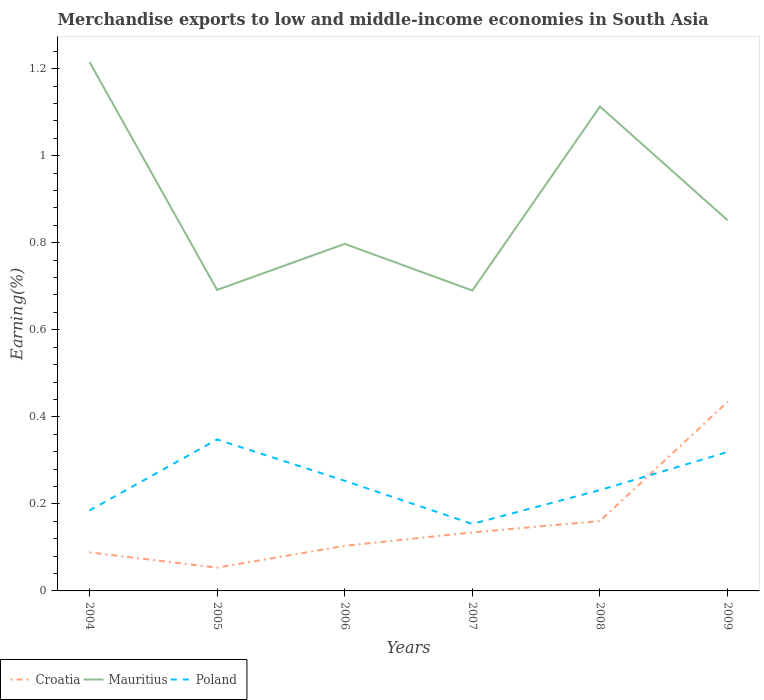How many different coloured lines are there?
Make the answer very short. 3. Does the line corresponding to Croatia intersect with the line corresponding to Poland?
Offer a very short reply. Yes. Across all years, what is the maximum percentage of amount earned from merchandise exports in Poland?
Your answer should be very brief. 0.15. What is the total percentage of amount earned from merchandise exports in Mauritius in the graph?
Provide a succinct answer. 0.36. What is the difference between the highest and the second highest percentage of amount earned from merchandise exports in Poland?
Give a very brief answer. 0.19. How many lines are there?
Offer a terse response. 3. Does the graph contain any zero values?
Offer a terse response. No. Does the graph contain grids?
Make the answer very short. No. Where does the legend appear in the graph?
Provide a short and direct response. Bottom left. How many legend labels are there?
Offer a very short reply. 3. How are the legend labels stacked?
Provide a succinct answer. Horizontal. What is the title of the graph?
Offer a terse response. Merchandise exports to low and middle-income economies in South Asia. Does "Netherlands" appear as one of the legend labels in the graph?
Offer a terse response. No. What is the label or title of the Y-axis?
Provide a succinct answer. Earning(%). What is the Earning(%) of Croatia in 2004?
Provide a succinct answer. 0.09. What is the Earning(%) in Mauritius in 2004?
Make the answer very short. 1.22. What is the Earning(%) in Poland in 2004?
Offer a very short reply. 0.18. What is the Earning(%) of Croatia in 2005?
Give a very brief answer. 0.05. What is the Earning(%) in Mauritius in 2005?
Offer a terse response. 0.69. What is the Earning(%) in Poland in 2005?
Your answer should be very brief. 0.35. What is the Earning(%) of Croatia in 2006?
Your answer should be compact. 0.1. What is the Earning(%) in Mauritius in 2006?
Give a very brief answer. 0.8. What is the Earning(%) in Poland in 2006?
Keep it short and to the point. 0.25. What is the Earning(%) in Croatia in 2007?
Provide a short and direct response. 0.13. What is the Earning(%) of Mauritius in 2007?
Provide a succinct answer. 0.69. What is the Earning(%) of Poland in 2007?
Your answer should be compact. 0.15. What is the Earning(%) in Croatia in 2008?
Make the answer very short. 0.16. What is the Earning(%) in Mauritius in 2008?
Your answer should be compact. 1.11. What is the Earning(%) in Poland in 2008?
Offer a terse response. 0.23. What is the Earning(%) in Croatia in 2009?
Offer a terse response. 0.43. What is the Earning(%) of Mauritius in 2009?
Provide a succinct answer. 0.85. What is the Earning(%) in Poland in 2009?
Your response must be concise. 0.32. Across all years, what is the maximum Earning(%) in Croatia?
Keep it short and to the point. 0.43. Across all years, what is the maximum Earning(%) in Mauritius?
Make the answer very short. 1.22. Across all years, what is the maximum Earning(%) of Poland?
Provide a short and direct response. 0.35. Across all years, what is the minimum Earning(%) of Croatia?
Your response must be concise. 0.05. Across all years, what is the minimum Earning(%) of Mauritius?
Give a very brief answer. 0.69. Across all years, what is the minimum Earning(%) of Poland?
Your response must be concise. 0.15. What is the total Earning(%) of Croatia in the graph?
Offer a very short reply. 0.98. What is the total Earning(%) of Mauritius in the graph?
Ensure brevity in your answer.  5.36. What is the total Earning(%) of Poland in the graph?
Ensure brevity in your answer.  1.49. What is the difference between the Earning(%) of Croatia in 2004 and that in 2005?
Give a very brief answer. 0.04. What is the difference between the Earning(%) in Mauritius in 2004 and that in 2005?
Your answer should be very brief. 0.52. What is the difference between the Earning(%) of Poland in 2004 and that in 2005?
Ensure brevity in your answer.  -0.16. What is the difference between the Earning(%) of Croatia in 2004 and that in 2006?
Provide a short and direct response. -0.02. What is the difference between the Earning(%) in Mauritius in 2004 and that in 2006?
Offer a very short reply. 0.42. What is the difference between the Earning(%) in Poland in 2004 and that in 2006?
Your answer should be very brief. -0.07. What is the difference between the Earning(%) in Croatia in 2004 and that in 2007?
Your answer should be very brief. -0.05. What is the difference between the Earning(%) in Mauritius in 2004 and that in 2007?
Your answer should be very brief. 0.53. What is the difference between the Earning(%) in Poland in 2004 and that in 2007?
Your answer should be very brief. 0.03. What is the difference between the Earning(%) of Croatia in 2004 and that in 2008?
Provide a short and direct response. -0.07. What is the difference between the Earning(%) of Mauritius in 2004 and that in 2008?
Keep it short and to the point. 0.1. What is the difference between the Earning(%) in Poland in 2004 and that in 2008?
Keep it short and to the point. -0.05. What is the difference between the Earning(%) in Croatia in 2004 and that in 2009?
Make the answer very short. -0.35. What is the difference between the Earning(%) in Mauritius in 2004 and that in 2009?
Provide a succinct answer. 0.36. What is the difference between the Earning(%) in Poland in 2004 and that in 2009?
Your answer should be very brief. -0.13. What is the difference between the Earning(%) in Croatia in 2005 and that in 2006?
Your answer should be very brief. -0.05. What is the difference between the Earning(%) of Mauritius in 2005 and that in 2006?
Ensure brevity in your answer.  -0.11. What is the difference between the Earning(%) of Poland in 2005 and that in 2006?
Provide a succinct answer. 0.1. What is the difference between the Earning(%) in Croatia in 2005 and that in 2007?
Your response must be concise. -0.08. What is the difference between the Earning(%) of Mauritius in 2005 and that in 2007?
Your answer should be very brief. 0. What is the difference between the Earning(%) of Poland in 2005 and that in 2007?
Offer a terse response. 0.19. What is the difference between the Earning(%) in Croatia in 2005 and that in 2008?
Your answer should be very brief. -0.11. What is the difference between the Earning(%) of Mauritius in 2005 and that in 2008?
Provide a succinct answer. -0.42. What is the difference between the Earning(%) in Poland in 2005 and that in 2008?
Provide a succinct answer. 0.12. What is the difference between the Earning(%) in Croatia in 2005 and that in 2009?
Your answer should be very brief. -0.38. What is the difference between the Earning(%) in Mauritius in 2005 and that in 2009?
Your answer should be compact. -0.16. What is the difference between the Earning(%) of Poland in 2005 and that in 2009?
Give a very brief answer. 0.03. What is the difference between the Earning(%) in Croatia in 2006 and that in 2007?
Ensure brevity in your answer.  -0.03. What is the difference between the Earning(%) of Mauritius in 2006 and that in 2007?
Your answer should be very brief. 0.11. What is the difference between the Earning(%) in Poland in 2006 and that in 2007?
Give a very brief answer. 0.1. What is the difference between the Earning(%) of Croatia in 2006 and that in 2008?
Provide a short and direct response. -0.06. What is the difference between the Earning(%) in Mauritius in 2006 and that in 2008?
Your answer should be very brief. -0.32. What is the difference between the Earning(%) in Poland in 2006 and that in 2008?
Your response must be concise. 0.02. What is the difference between the Earning(%) of Croatia in 2006 and that in 2009?
Your answer should be compact. -0.33. What is the difference between the Earning(%) in Mauritius in 2006 and that in 2009?
Provide a short and direct response. -0.05. What is the difference between the Earning(%) in Poland in 2006 and that in 2009?
Ensure brevity in your answer.  -0.07. What is the difference between the Earning(%) in Croatia in 2007 and that in 2008?
Give a very brief answer. -0.03. What is the difference between the Earning(%) in Mauritius in 2007 and that in 2008?
Provide a succinct answer. -0.42. What is the difference between the Earning(%) of Poland in 2007 and that in 2008?
Offer a terse response. -0.08. What is the difference between the Earning(%) of Croatia in 2007 and that in 2009?
Provide a short and direct response. -0.3. What is the difference between the Earning(%) of Mauritius in 2007 and that in 2009?
Make the answer very short. -0.16. What is the difference between the Earning(%) of Poland in 2007 and that in 2009?
Your response must be concise. -0.17. What is the difference between the Earning(%) in Croatia in 2008 and that in 2009?
Provide a succinct answer. -0.27. What is the difference between the Earning(%) of Mauritius in 2008 and that in 2009?
Your answer should be compact. 0.26. What is the difference between the Earning(%) in Poland in 2008 and that in 2009?
Your answer should be compact. -0.09. What is the difference between the Earning(%) in Croatia in 2004 and the Earning(%) in Mauritius in 2005?
Give a very brief answer. -0.6. What is the difference between the Earning(%) of Croatia in 2004 and the Earning(%) of Poland in 2005?
Your answer should be very brief. -0.26. What is the difference between the Earning(%) in Mauritius in 2004 and the Earning(%) in Poland in 2005?
Keep it short and to the point. 0.87. What is the difference between the Earning(%) of Croatia in 2004 and the Earning(%) of Mauritius in 2006?
Give a very brief answer. -0.71. What is the difference between the Earning(%) in Croatia in 2004 and the Earning(%) in Poland in 2006?
Provide a succinct answer. -0.16. What is the difference between the Earning(%) of Mauritius in 2004 and the Earning(%) of Poland in 2006?
Keep it short and to the point. 0.96. What is the difference between the Earning(%) in Croatia in 2004 and the Earning(%) in Mauritius in 2007?
Provide a succinct answer. -0.6. What is the difference between the Earning(%) of Croatia in 2004 and the Earning(%) of Poland in 2007?
Provide a succinct answer. -0.07. What is the difference between the Earning(%) of Mauritius in 2004 and the Earning(%) of Poland in 2007?
Give a very brief answer. 1.06. What is the difference between the Earning(%) in Croatia in 2004 and the Earning(%) in Mauritius in 2008?
Provide a succinct answer. -1.02. What is the difference between the Earning(%) in Croatia in 2004 and the Earning(%) in Poland in 2008?
Offer a very short reply. -0.14. What is the difference between the Earning(%) of Mauritius in 2004 and the Earning(%) of Poland in 2008?
Your answer should be compact. 0.98. What is the difference between the Earning(%) in Croatia in 2004 and the Earning(%) in Mauritius in 2009?
Provide a short and direct response. -0.76. What is the difference between the Earning(%) of Croatia in 2004 and the Earning(%) of Poland in 2009?
Make the answer very short. -0.23. What is the difference between the Earning(%) in Mauritius in 2004 and the Earning(%) in Poland in 2009?
Provide a succinct answer. 0.9. What is the difference between the Earning(%) of Croatia in 2005 and the Earning(%) of Mauritius in 2006?
Provide a succinct answer. -0.74. What is the difference between the Earning(%) of Croatia in 2005 and the Earning(%) of Poland in 2006?
Make the answer very short. -0.2. What is the difference between the Earning(%) in Mauritius in 2005 and the Earning(%) in Poland in 2006?
Offer a terse response. 0.44. What is the difference between the Earning(%) in Croatia in 2005 and the Earning(%) in Mauritius in 2007?
Your answer should be very brief. -0.64. What is the difference between the Earning(%) of Croatia in 2005 and the Earning(%) of Poland in 2007?
Provide a succinct answer. -0.1. What is the difference between the Earning(%) of Mauritius in 2005 and the Earning(%) of Poland in 2007?
Ensure brevity in your answer.  0.54. What is the difference between the Earning(%) in Croatia in 2005 and the Earning(%) in Mauritius in 2008?
Make the answer very short. -1.06. What is the difference between the Earning(%) of Croatia in 2005 and the Earning(%) of Poland in 2008?
Provide a short and direct response. -0.18. What is the difference between the Earning(%) of Mauritius in 2005 and the Earning(%) of Poland in 2008?
Ensure brevity in your answer.  0.46. What is the difference between the Earning(%) of Croatia in 2005 and the Earning(%) of Mauritius in 2009?
Provide a succinct answer. -0.8. What is the difference between the Earning(%) of Croatia in 2005 and the Earning(%) of Poland in 2009?
Provide a succinct answer. -0.27. What is the difference between the Earning(%) in Mauritius in 2005 and the Earning(%) in Poland in 2009?
Offer a very short reply. 0.37. What is the difference between the Earning(%) in Croatia in 2006 and the Earning(%) in Mauritius in 2007?
Give a very brief answer. -0.59. What is the difference between the Earning(%) of Croatia in 2006 and the Earning(%) of Poland in 2007?
Ensure brevity in your answer.  -0.05. What is the difference between the Earning(%) of Mauritius in 2006 and the Earning(%) of Poland in 2007?
Your response must be concise. 0.64. What is the difference between the Earning(%) in Croatia in 2006 and the Earning(%) in Mauritius in 2008?
Make the answer very short. -1.01. What is the difference between the Earning(%) of Croatia in 2006 and the Earning(%) of Poland in 2008?
Offer a terse response. -0.13. What is the difference between the Earning(%) in Mauritius in 2006 and the Earning(%) in Poland in 2008?
Offer a very short reply. 0.57. What is the difference between the Earning(%) in Croatia in 2006 and the Earning(%) in Mauritius in 2009?
Your response must be concise. -0.75. What is the difference between the Earning(%) in Croatia in 2006 and the Earning(%) in Poland in 2009?
Offer a very short reply. -0.22. What is the difference between the Earning(%) in Mauritius in 2006 and the Earning(%) in Poland in 2009?
Offer a very short reply. 0.48. What is the difference between the Earning(%) in Croatia in 2007 and the Earning(%) in Mauritius in 2008?
Your answer should be very brief. -0.98. What is the difference between the Earning(%) of Croatia in 2007 and the Earning(%) of Poland in 2008?
Ensure brevity in your answer.  -0.1. What is the difference between the Earning(%) of Mauritius in 2007 and the Earning(%) of Poland in 2008?
Your response must be concise. 0.46. What is the difference between the Earning(%) in Croatia in 2007 and the Earning(%) in Mauritius in 2009?
Your response must be concise. -0.72. What is the difference between the Earning(%) in Croatia in 2007 and the Earning(%) in Poland in 2009?
Provide a succinct answer. -0.18. What is the difference between the Earning(%) of Mauritius in 2007 and the Earning(%) of Poland in 2009?
Ensure brevity in your answer.  0.37. What is the difference between the Earning(%) of Croatia in 2008 and the Earning(%) of Mauritius in 2009?
Provide a short and direct response. -0.69. What is the difference between the Earning(%) in Croatia in 2008 and the Earning(%) in Poland in 2009?
Make the answer very short. -0.16. What is the difference between the Earning(%) of Mauritius in 2008 and the Earning(%) of Poland in 2009?
Provide a succinct answer. 0.79. What is the average Earning(%) of Croatia per year?
Make the answer very short. 0.16. What is the average Earning(%) in Mauritius per year?
Your answer should be very brief. 0.89. What is the average Earning(%) in Poland per year?
Offer a terse response. 0.25. In the year 2004, what is the difference between the Earning(%) of Croatia and Earning(%) of Mauritius?
Provide a succinct answer. -1.13. In the year 2004, what is the difference between the Earning(%) of Croatia and Earning(%) of Poland?
Keep it short and to the point. -0.1. In the year 2004, what is the difference between the Earning(%) in Mauritius and Earning(%) in Poland?
Offer a terse response. 1.03. In the year 2005, what is the difference between the Earning(%) in Croatia and Earning(%) in Mauritius?
Keep it short and to the point. -0.64. In the year 2005, what is the difference between the Earning(%) in Croatia and Earning(%) in Poland?
Your response must be concise. -0.29. In the year 2005, what is the difference between the Earning(%) in Mauritius and Earning(%) in Poland?
Offer a terse response. 0.34. In the year 2006, what is the difference between the Earning(%) of Croatia and Earning(%) of Mauritius?
Your response must be concise. -0.69. In the year 2006, what is the difference between the Earning(%) in Croatia and Earning(%) in Poland?
Provide a short and direct response. -0.15. In the year 2006, what is the difference between the Earning(%) of Mauritius and Earning(%) of Poland?
Your answer should be very brief. 0.54. In the year 2007, what is the difference between the Earning(%) of Croatia and Earning(%) of Mauritius?
Give a very brief answer. -0.56. In the year 2007, what is the difference between the Earning(%) of Croatia and Earning(%) of Poland?
Offer a very short reply. -0.02. In the year 2007, what is the difference between the Earning(%) in Mauritius and Earning(%) in Poland?
Offer a very short reply. 0.54. In the year 2008, what is the difference between the Earning(%) of Croatia and Earning(%) of Mauritius?
Give a very brief answer. -0.95. In the year 2008, what is the difference between the Earning(%) in Croatia and Earning(%) in Poland?
Offer a very short reply. -0.07. In the year 2008, what is the difference between the Earning(%) of Mauritius and Earning(%) of Poland?
Provide a short and direct response. 0.88. In the year 2009, what is the difference between the Earning(%) of Croatia and Earning(%) of Mauritius?
Your answer should be compact. -0.42. In the year 2009, what is the difference between the Earning(%) of Croatia and Earning(%) of Poland?
Provide a short and direct response. 0.12. In the year 2009, what is the difference between the Earning(%) in Mauritius and Earning(%) in Poland?
Make the answer very short. 0.53. What is the ratio of the Earning(%) in Croatia in 2004 to that in 2005?
Offer a terse response. 1.65. What is the ratio of the Earning(%) of Mauritius in 2004 to that in 2005?
Keep it short and to the point. 1.76. What is the ratio of the Earning(%) of Poland in 2004 to that in 2005?
Provide a short and direct response. 0.53. What is the ratio of the Earning(%) of Croatia in 2004 to that in 2006?
Keep it short and to the point. 0.85. What is the ratio of the Earning(%) of Mauritius in 2004 to that in 2006?
Ensure brevity in your answer.  1.52. What is the ratio of the Earning(%) in Poland in 2004 to that in 2006?
Your answer should be very brief. 0.73. What is the ratio of the Earning(%) in Croatia in 2004 to that in 2007?
Give a very brief answer. 0.66. What is the ratio of the Earning(%) of Mauritius in 2004 to that in 2007?
Provide a succinct answer. 1.76. What is the ratio of the Earning(%) in Poland in 2004 to that in 2007?
Your response must be concise. 1.2. What is the ratio of the Earning(%) of Croatia in 2004 to that in 2008?
Your answer should be compact. 0.55. What is the ratio of the Earning(%) in Mauritius in 2004 to that in 2008?
Your answer should be very brief. 1.09. What is the ratio of the Earning(%) in Poland in 2004 to that in 2008?
Offer a terse response. 0.8. What is the ratio of the Earning(%) in Croatia in 2004 to that in 2009?
Your response must be concise. 0.2. What is the ratio of the Earning(%) of Mauritius in 2004 to that in 2009?
Offer a terse response. 1.43. What is the ratio of the Earning(%) in Poland in 2004 to that in 2009?
Provide a succinct answer. 0.58. What is the ratio of the Earning(%) of Croatia in 2005 to that in 2006?
Make the answer very short. 0.52. What is the ratio of the Earning(%) of Mauritius in 2005 to that in 2006?
Keep it short and to the point. 0.87. What is the ratio of the Earning(%) of Poland in 2005 to that in 2006?
Keep it short and to the point. 1.38. What is the ratio of the Earning(%) in Croatia in 2005 to that in 2007?
Offer a very short reply. 0.4. What is the ratio of the Earning(%) in Poland in 2005 to that in 2007?
Keep it short and to the point. 2.26. What is the ratio of the Earning(%) in Croatia in 2005 to that in 2008?
Provide a short and direct response. 0.33. What is the ratio of the Earning(%) of Mauritius in 2005 to that in 2008?
Your response must be concise. 0.62. What is the ratio of the Earning(%) in Poland in 2005 to that in 2008?
Your answer should be very brief. 1.5. What is the ratio of the Earning(%) of Croatia in 2005 to that in 2009?
Ensure brevity in your answer.  0.12. What is the ratio of the Earning(%) in Mauritius in 2005 to that in 2009?
Provide a succinct answer. 0.81. What is the ratio of the Earning(%) of Poland in 2005 to that in 2009?
Offer a terse response. 1.09. What is the ratio of the Earning(%) of Croatia in 2006 to that in 2007?
Make the answer very short. 0.77. What is the ratio of the Earning(%) in Mauritius in 2006 to that in 2007?
Ensure brevity in your answer.  1.16. What is the ratio of the Earning(%) in Poland in 2006 to that in 2007?
Keep it short and to the point. 1.64. What is the ratio of the Earning(%) in Croatia in 2006 to that in 2008?
Ensure brevity in your answer.  0.65. What is the ratio of the Earning(%) in Mauritius in 2006 to that in 2008?
Ensure brevity in your answer.  0.72. What is the ratio of the Earning(%) of Poland in 2006 to that in 2008?
Offer a terse response. 1.09. What is the ratio of the Earning(%) of Croatia in 2006 to that in 2009?
Your response must be concise. 0.24. What is the ratio of the Earning(%) in Mauritius in 2006 to that in 2009?
Offer a very short reply. 0.94. What is the ratio of the Earning(%) in Poland in 2006 to that in 2009?
Your response must be concise. 0.79. What is the ratio of the Earning(%) of Croatia in 2007 to that in 2008?
Ensure brevity in your answer.  0.84. What is the ratio of the Earning(%) in Mauritius in 2007 to that in 2008?
Offer a very short reply. 0.62. What is the ratio of the Earning(%) in Poland in 2007 to that in 2008?
Keep it short and to the point. 0.66. What is the ratio of the Earning(%) in Croatia in 2007 to that in 2009?
Provide a succinct answer. 0.31. What is the ratio of the Earning(%) in Mauritius in 2007 to that in 2009?
Your response must be concise. 0.81. What is the ratio of the Earning(%) of Poland in 2007 to that in 2009?
Keep it short and to the point. 0.48. What is the ratio of the Earning(%) of Croatia in 2008 to that in 2009?
Your response must be concise. 0.37. What is the ratio of the Earning(%) in Mauritius in 2008 to that in 2009?
Make the answer very short. 1.31. What is the ratio of the Earning(%) in Poland in 2008 to that in 2009?
Provide a succinct answer. 0.73. What is the difference between the highest and the second highest Earning(%) of Croatia?
Your response must be concise. 0.27. What is the difference between the highest and the second highest Earning(%) in Mauritius?
Make the answer very short. 0.1. What is the difference between the highest and the second highest Earning(%) in Poland?
Provide a short and direct response. 0.03. What is the difference between the highest and the lowest Earning(%) of Croatia?
Give a very brief answer. 0.38. What is the difference between the highest and the lowest Earning(%) in Mauritius?
Your answer should be very brief. 0.53. What is the difference between the highest and the lowest Earning(%) in Poland?
Make the answer very short. 0.19. 